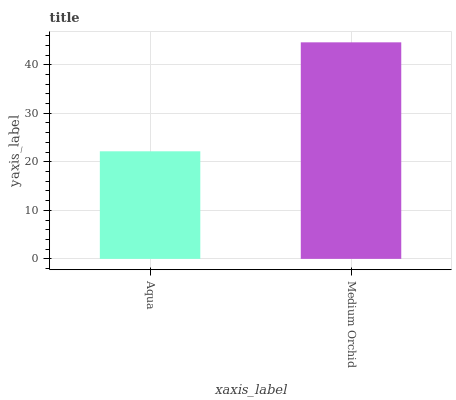Is Aqua the minimum?
Answer yes or no. Yes. Is Medium Orchid the maximum?
Answer yes or no. Yes. Is Medium Orchid the minimum?
Answer yes or no. No. Is Medium Orchid greater than Aqua?
Answer yes or no. Yes. Is Aqua less than Medium Orchid?
Answer yes or no. Yes. Is Aqua greater than Medium Orchid?
Answer yes or no. No. Is Medium Orchid less than Aqua?
Answer yes or no. No. Is Medium Orchid the high median?
Answer yes or no. Yes. Is Aqua the low median?
Answer yes or no. Yes. Is Aqua the high median?
Answer yes or no. No. Is Medium Orchid the low median?
Answer yes or no. No. 